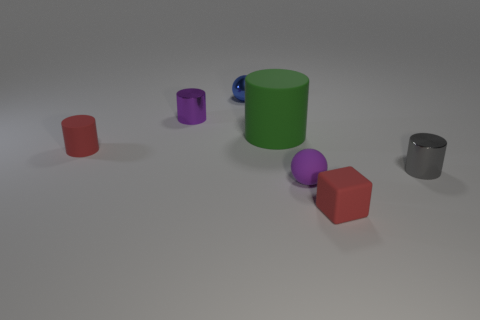What textures do the surfaces of the objects appear to have? The surfaces of the objects seem to have a matte finish with slight variations in specularity, giving a subtle reflection that suggests a rubbery texture. 